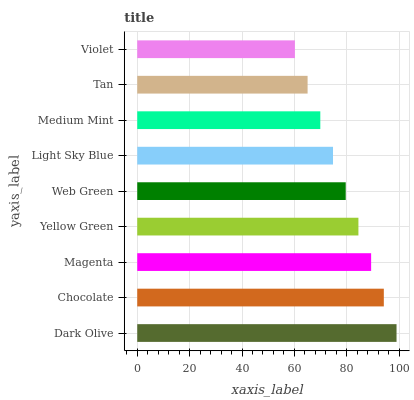Is Violet the minimum?
Answer yes or no. Yes. Is Dark Olive the maximum?
Answer yes or no. Yes. Is Chocolate the minimum?
Answer yes or no. No. Is Chocolate the maximum?
Answer yes or no. No. Is Dark Olive greater than Chocolate?
Answer yes or no. Yes. Is Chocolate less than Dark Olive?
Answer yes or no. Yes. Is Chocolate greater than Dark Olive?
Answer yes or no. No. Is Dark Olive less than Chocolate?
Answer yes or no. No. Is Web Green the high median?
Answer yes or no. Yes. Is Web Green the low median?
Answer yes or no. Yes. Is Chocolate the high median?
Answer yes or no. No. Is Tan the low median?
Answer yes or no. No. 